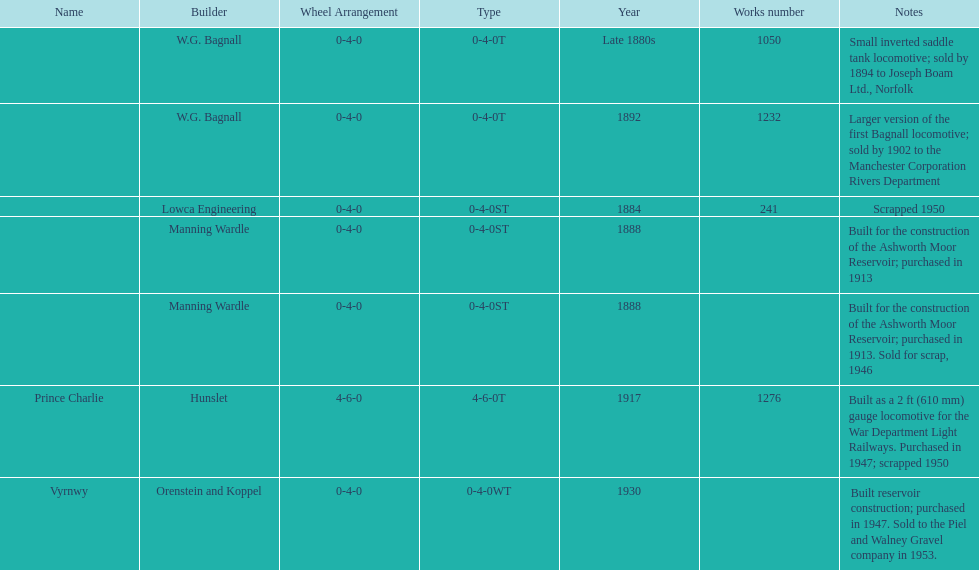Parse the full table. {'header': ['Name', 'Builder', 'Wheel Arrangement', 'Type', 'Year', 'Works number', 'Notes'], 'rows': [['', 'W.G. Bagnall', '0-4-0', '0-4-0T', 'Late 1880s', '1050', 'Small inverted saddle tank locomotive; sold by 1894 to Joseph Boam Ltd., Norfolk'], ['', 'W.G. Bagnall', '0-4-0', '0-4-0T', '1892', '1232', 'Larger version of the first Bagnall locomotive; sold by 1902 to the Manchester Corporation Rivers Department'], ['', 'Lowca Engineering', '0-4-0', '0-4-0ST', '1884', '241', 'Scrapped 1950'], ['', 'Manning Wardle', '0-4-0', '0-4-0ST', '1888', '', 'Built for the construction of the Ashworth Moor Reservoir; purchased in 1913'], ['', 'Manning Wardle', '0-4-0', '0-4-0ST', '1888', '', 'Built for the construction of the Ashworth Moor Reservoir; purchased in 1913. Sold for scrap, 1946'], ['Prince Charlie', 'Hunslet', '4-6-0', '4-6-0T', '1917', '1276', 'Built as a 2\xa0ft (610\xa0mm) gauge locomotive for the War Department Light Railways. Purchased in 1947; scrapped 1950'], ['Vyrnwy', 'Orenstein and Koppel', '0-4-0', '0-4-0WT', '1930', '', 'Built reservoir construction; purchased in 1947. Sold to the Piel and Walney Gravel company in 1953.']]} List each of the builder's that had a locomotive scrapped. Lowca Engineering, Manning Wardle, Hunslet. 